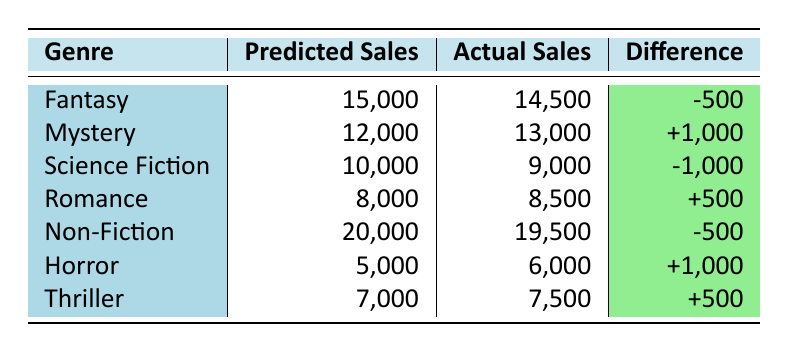What are the predicted sales for the Romance genre? The table shows the predicted sales for the Romance genre as 8,000.
Answer: 8,000 What is the actual sales figure for Non-Fiction? According to the table, the actual sales figure for Non-Fiction is 19,500.
Answer: 19,500 In which genre did the predicted sales underperform compared to actual sales? Looking at the table, Science Fiction had predicted sales of 10,000 but actual sales of only 9,000, indicating it underperformed.
Answer: Science Fiction What is the total difference between predicted and actual sales for all genres combined? To find the total difference, we sum the differences: (-500) + (1,000) + (-1,000) + (500) + (-500) + (1,000) + (500) = 0. So the total difference is 0.
Answer: 0 Is it true that the predicted sales for Horror were lower than actual sales? The table shows that the predicted sales for Horror were 5,000 and actual sales were 6,000, which means it is true that the predicted sales were lower.
Answer: Yes What genre had the highest positive difference between predicted and actual sales? We examine the differences: Mystery: 1,000, Horror: 1,000, Romance: 500, and Thriller: 500. The highest positive difference belongs to both Mystery and Horror, with a difference of 1,000.
Answer: Mystery and Horror How many genres had a negative difference in predicted and actual sales? The table indicates that Science Fiction, Fantasy, and Non-Fiction had negative differences, for a total of 3 genres.
Answer: 3 What is the average predicted sales across all genres? To calculate the average, sum the predicted sales (15,000 + 12,000 + 10,000 + 8,000 + 20,000 + 5,000 + 7,000) = 77,000 across 7 genres, so the average is 77,000/7 ≈ 11,000.
Answer: 11,000 